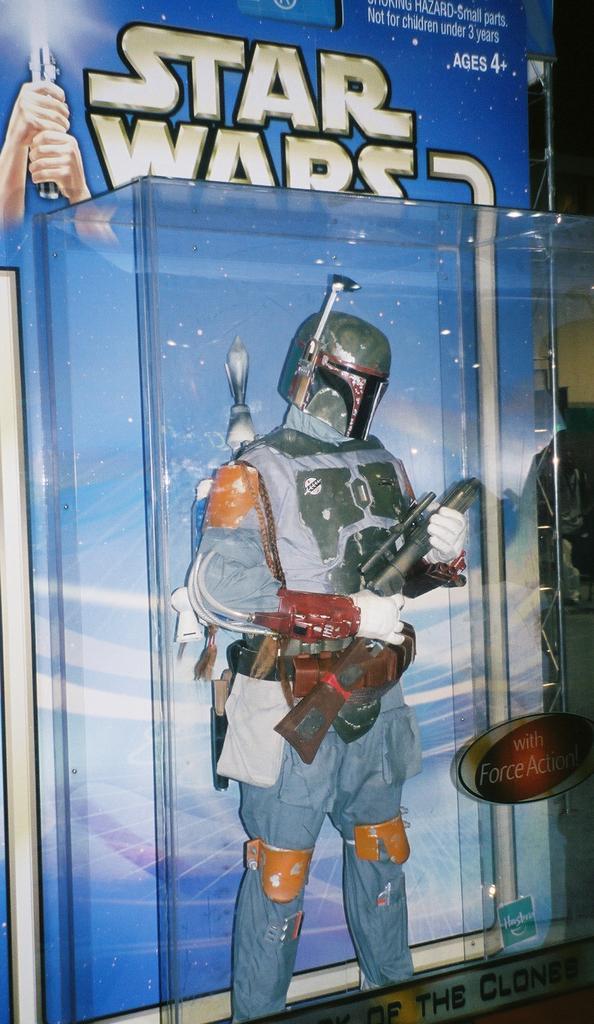Can you describe this image briefly? In this picture we can observe a toy which is holding a gun in its hand. We can observe a helmet. This toy is packed in a plastic box. We can observe blue color background. 